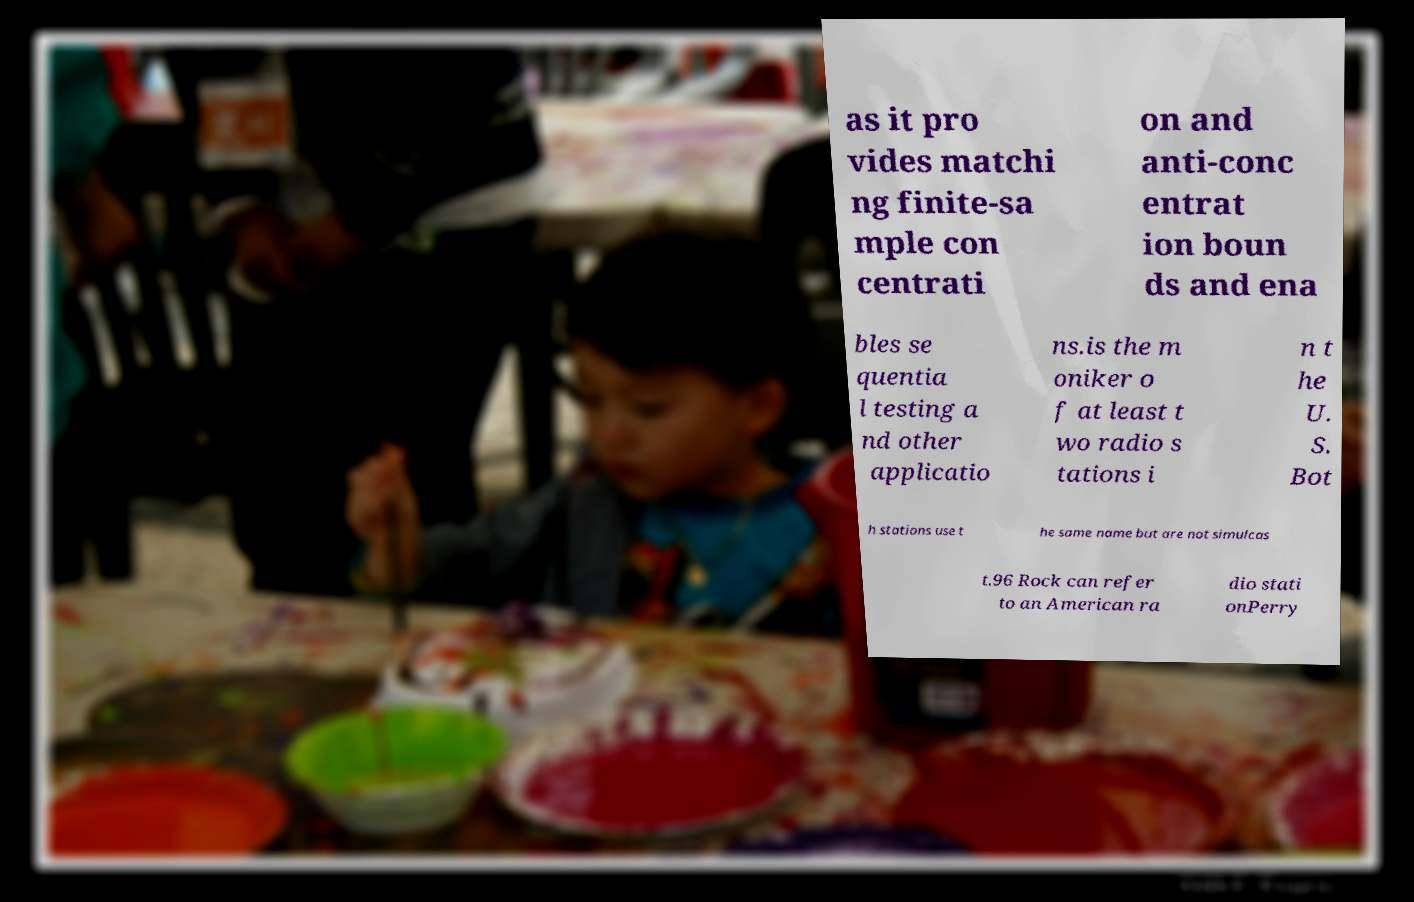For documentation purposes, I need the text within this image transcribed. Could you provide that? as it pro vides matchi ng finite-sa mple con centrati on and anti-conc entrat ion boun ds and ena bles se quentia l testing a nd other applicatio ns.is the m oniker o f at least t wo radio s tations i n t he U. S. Bot h stations use t he same name but are not simulcas t.96 Rock can refer to an American ra dio stati onPerry 